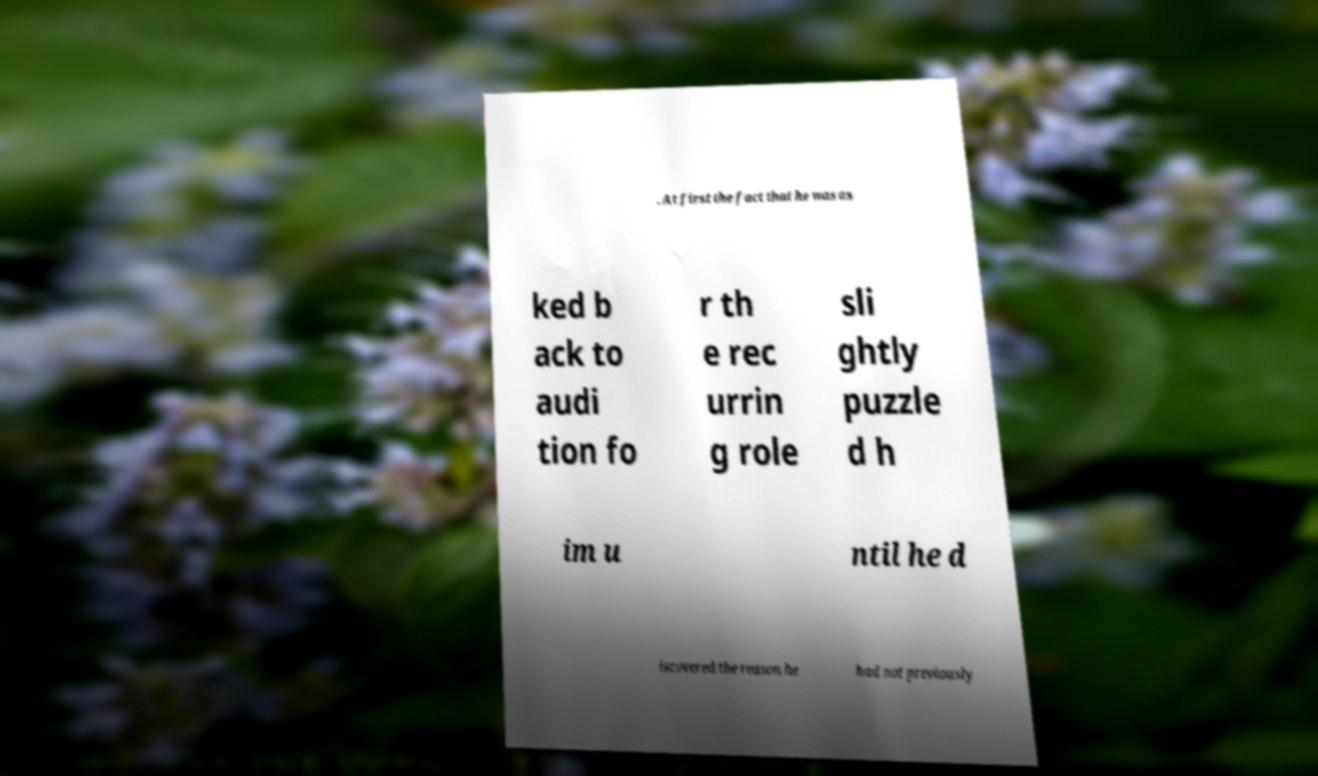What messages or text are displayed in this image? I need them in a readable, typed format. . At first the fact that he was as ked b ack to audi tion fo r th e rec urrin g role sli ghtly puzzle d h im u ntil he d iscovered the reason he had not previously 